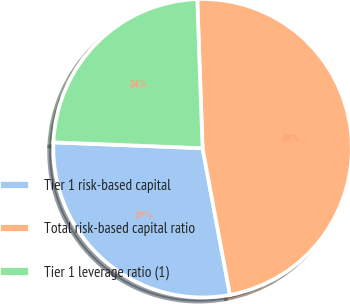Convert chart to OTSL. <chart><loc_0><loc_0><loc_500><loc_500><pie_chart><fcel>Tier 1 risk-based capital<fcel>Total risk-based capital ratio<fcel>Tier 1 leverage ratio (1)<nl><fcel>28.57%<fcel>47.62%<fcel>23.81%<nl></chart> 